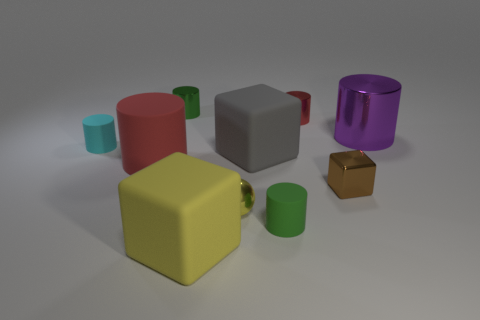Subtract all red cubes. How many green cylinders are left? 2 Subtract 1 cylinders. How many cylinders are left? 5 Subtract all cyan cylinders. How many cylinders are left? 5 Subtract all rubber blocks. How many blocks are left? 1 Subtract all yellow cylinders. Subtract all purple spheres. How many cylinders are left? 6 Subtract all cylinders. How many objects are left? 4 Add 3 matte cubes. How many matte cubes exist? 5 Subtract 0 yellow cylinders. How many objects are left? 10 Subtract all big red objects. Subtract all shiny things. How many objects are left? 4 Add 6 small cyan matte cylinders. How many small cyan matte cylinders are left? 7 